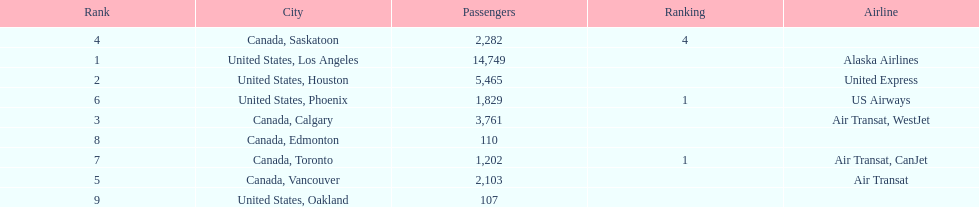Which airline carries the most passengers? Alaska Airlines. 